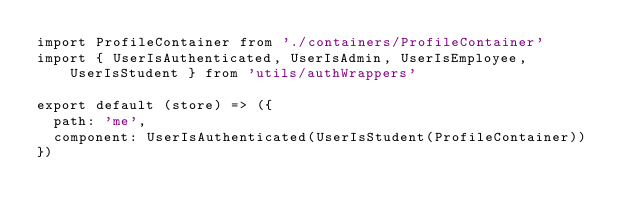<code> <loc_0><loc_0><loc_500><loc_500><_JavaScript_>import ProfileContainer from './containers/ProfileContainer'
import { UserIsAuthenticated, UserIsAdmin, UserIsEmployee, UserIsStudent } from 'utils/authWrappers'

export default (store) => ({
  path: 'me',
  component: UserIsAuthenticated(UserIsStudent(ProfileContainer))
})
</code> 